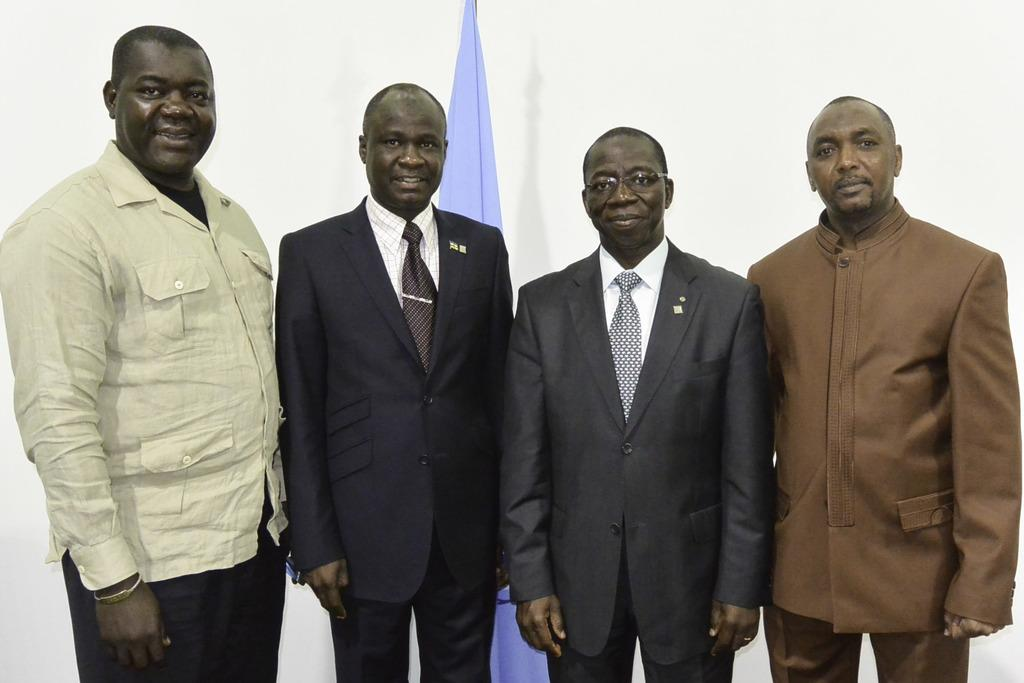How many people are in the image? There is a group of people in the image, but the exact number is not specified. What can be seen in the background of the image? Cloth is visible in the background of the image. How many umbrellas are being held by the girls in the image? There is no mention of girls or umbrellas in the image, so we cannot answer this question. 